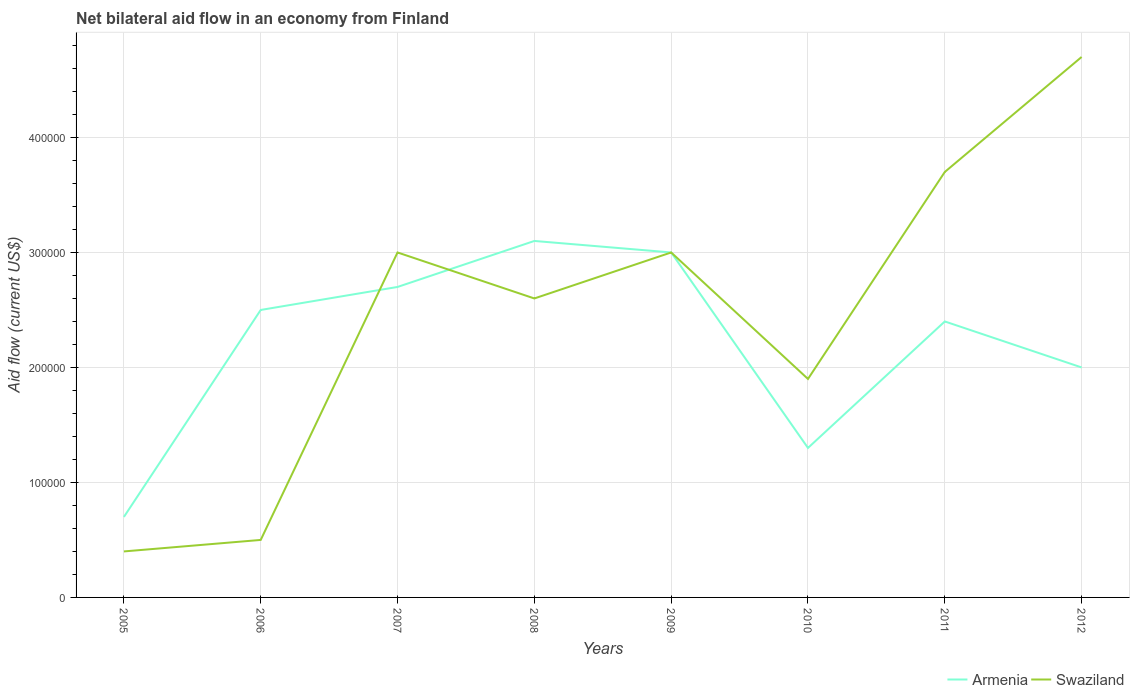How many different coloured lines are there?
Offer a very short reply. 2. In which year was the net bilateral aid flow in Swaziland maximum?
Make the answer very short. 2005. What is the total net bilateral aid flow in Armenia in the graph?
Provide a short and direct response. -1.80e+05. What is the difference between the highest and the second highest net bilateral aid flow in Swaziland?
Ensure brevity in your answer.  4.30e+05. Is the net bilateral aid flow in Armenia strictly greater than the net bilateral aid flow in Swaziland over the years?
Make the answer very short. No. How many years are there in the graph?
Your response must be concise. 8. What is the difference between two consecutive major ticks on the Y-axis?
Provide a succinct answer. 1.00e+05. Are the values on the major ticks of Y-axis written in scientific E-notation?
Provide a succinct answer. No. Does the graph contain grids?
Keep it short and to the point. Yes. Where does the legend appear in the graph?
Your response must be concise. Bottom right. How many legend labels are there?
Give a very brief answer. 2. What is the title of the graph?
Give a very brief answer. Net bilateral aid flow in an economy from Finland. Does "South Sudan" appear as one of the legend labels in the graph?
Provide a succinct answer. No. What is the Aid flow (current US$) in Armenia in 2005?
Give a very brief answer. 7.00e+04. What is the Aid flow (current US$) of Swaziland in 2005?
Your answer should be very brief. 4.00e+04. What is the Aid flow (current US$) in Armenia in 2007?
Provide a succinct answer. 2.70e+05. What is the Aid flow (current US$) of Armenia in 2008?
Your answer should be very brief. 3.10e+05. What is the Aid flow (current US$) of Swaziland in 2010?
Your answer should be compact. 1.90e+05. What is the Aid flow (current US$) of Swaziland in 2011?
Keep it short and to the point. 3.70e+05. What is the Aid flow (current US$) in Armenia in 2012?
Provide a short and direct response. 2.00e+05. What is the Aid flow (current US$) of Swaziland in 2012?
Provide a succinct answer. 4.70e+05. Across all years, what is the minimum Aid flow (current US$) of Armenia?
Your answer should be compact. 7.00e+04. What is the total Aid flow (current US$) of Armenia in the graph?
Your answer should be very brief. 1.77e+06. What is the total Aid flow (current US$) in Swaziland in the graph?
Offer a very short reply. 1.98e+06. What is the difference between the Aid flow (current US$) in Armenia in 2005 and that in 2006?
Give a very brief answer. -1.80e+05. What is the difference between the Aid flow (current US$) in Swaziland in 2005 and that in 2006?
Offer a very short reply. -10000. What is the difference between the Aid flow (current US$) in Armenia in 2005 and that in 2007?
Keep it short and to the point. -2.00e+05. What is the difference between the Aid flow (current US$) of Swaziland in 2005 and that in 2007?
Offer a terse response. -2.60e+05. What is the difference between the Aid flow (current US$) in Armenia in 2005 and that in 2008?
Give a very brief answer. -2.40e+05. What is the difference between the Aid flow (current US$) in Swaziland in 2005 and that in 2008?
Your answer should be very brief. -2.20e+05. What is the difference between the Aid flow (current US$) in Swaziland in 2005 and that in 2009?
Your answer should be compact. -2.60e+05. What is the difference between the Aid flow (current US$) in Armenia in 2005 and that in 2011?
Ensure brevity in your answer.  -1.70e+05. What is the difference between the Aid flow (current US$) of Swaziland in 2005 and that in 2011?
Give a very brief answer. -3.30e+05. What is the difference between the Aid flow (current US$) of Swaziland in 2005 and that in 2012?
Your answer should be very brief. -4.30e+05. What is the difference between the Aid flow (current US$) of Swaziland in 2006 and that in 2007?
Keep it short and to the point. -2.50e+05. What is the difference between the Aid flow (current US$) of Swaziland in 2006 and that in 2010?
Make the answer very short. -1.40e+05. What is the difference between the Aid flow (current US$) of Swaziland in 2006 and that in 2011?
Offer a very short reply. -3.20e+05. What is the difference between the Aid flow (current US$) of Swaziland in 2006 and that in 2012?
Provide a succinct answer. -4.20e+05. What is the difference between the Aid flow (current US$) in Armenia in 2007 and that in 2009?
Give a very brief answer. -3.00e+04. What is the difference between the Aid flow (current US$) in Swaziland in 2007 and that in 2009?
Your answer should be compact. 0. What is the difference between the Aid flow (current US$) in Armenia in 2007 and that in 2010?
Offer a very short reply. 1.40e+05. What is the difference between the Aid flow (current US$) of Swaziland in 2007 and that in 2010?
Offer a very short reply. 1.10e+05. What is the difference between the Aid flow (current US$) in Armenia in 2007 and that in 2011?
Make the answer very short. 3.00e+04. What is the difference between the Aid flow (current US$) of Armenia in 2007 and that in 2012?
Give a very brief answer. 7.00e+04. What is the difference between the Aid flow (current US$) of Armenia in 2008 and that in 2009?
Provide a short and direct response. 10000. What is the difference between the Aid flow (current US$) in Swaziland in 2008 and that in 2009?
Keep it short and to the point. -4.00e+04. What is the difference between the Aid flow (current US$) in Swaziland in 2008 and that in 2010?
Ensure brevity in your answer.  7.00e+04. What is the difference between the Aid flow (current US$) in Armenia in 2008 and that in 2011?
Your response must be concise. 7.00e+04. What is the difference between the Aid flow (current US$) in Armenia in 2008 and that in 2012?
Offer a terse response. 1.10e+05. What is the difference between the Aid flow (current US$) of Armenia in 2009 and that in 2010?
Provide a succinct answer. 1.70e+05. What is the difference between the Aid flow (current US$) in Swaziland in 2009 and that in 2011?
Provide a short and direct response. -7.00e+04. What is the difference between the Aid flow (current US$) of Armenia in 2009 and that in 2012?
Make the answer very short. 1.00e+05. What is the difference between the Aid flow (current US$) of Armenia in 2010 and that in 2011?
Ensure brevity in your answer.  -1.10e+05. What is the difference between the Aid flow (current US$) of Swaziland in 2010 and that in 2012?
Offer a very short reply. -2.80e+05. What is the difference between the Aid flow (current US$) of Armenia in 2005 and the Aid flow (current US$) of Swaziland in 2007?
Provide a short and direct response. -2.30e+05. What is the difference between the Aid flow (current US$) in Armenia in 2005 and the Aid flow (current US$) in Swaziland in 2012?
Provide a short and direct response. -4.00e+05. What is the difference between the Aid flow (current US$) in Armenia in 2006 and the Aid flow (current US$) in Swaziland in 2008?
Provide a succinct answer. -10000. What is the difference between the Aid flow (current US$) of Armenia in 2007 and the Aid flow (current US$) of Swaziland in 2009?
Ensure brevity in your answer.  -3.00e+04. What is the difference between the Aid flow (current US$) of Armenia in 2008 and the Aid flow (current US$) of Swaziland in 2009?
Offer a very short reply. 10000. What is the difference between the Aid flow (current US$) of Armenia in 2008 and the Aid flow (current US$) of Swaziland in 2010?
Give a very brief answer. 1.20e+05. What is the difference between the Aid flow (current US$) of Armenia in 2008 and the Aid flow (current US$) of Swaziland in 2011?
Your answer should be compact. -6.00e+04. What is the difference between the Aid flow (current US$) in Armenia in 2009 and the Aid flow (current US$) in Swaziland in 2011?
Keep it short and to the point. -7.00e+04. What is the difference between the Aid flow (current US$) of Armenia in 2010 and the Aid flow (current US$) of Swaziland in 2011?
Your answer should be very brief. -2.40e+05. What is the average Aid flow (current US$) in Armenia per year?
Offer a very short reply. 2.21e+05. What is the average Aid flow (current US$) in Swaziland per year?
Offer a terse response. 2.48e+05. In the year 2006, what is the difference between the Aid flow (current US$) in Armenia and Aid flow (current US$) in Swaziland?
Your answer should be very brief. 2.00e+05. In the year 2007, what is the difference between the Aid flow (current US$) in Armenia and Aid flow (current US$) in Swaziland?
Offer a very short reply. -3.00e+04. In the year 2010, what is the difference between the Aid flow (current US$) in Armenia and Aid flow (current US$) in Swaziland?
Ensure brevity in your answer.  -6.00e+04. In the year 2011, what is the difference between the Aid flow (current US$) of Armenia and Aid flow (current US$) of Swaziland?
Provide a succinct answer. -1.30e+05. In the year 2012, what is the difference between the Aid flow (current US$) of Armenia and Aid flow (current US$) of Swaziland?
Your response must be concise. -2.70e+05. What is the ratio of the Aid flow (current US$) of Armenia in 2005 to that in 2006?
Provide a short and direct response. 0.28. What is the ratio of the Aid flow (current US$) of Armenia in 2005 to that in 2007?
Give a very brief answer. 0.26. What is the ratio of the Aid flow (current US$) in Swaziland in 2005 to that in 2007?
Provide a short and direct response. 0.13. What is the ratio of the Aid flow (current US$) in Armenia in 2005 to that in 2008?
Make the answer very short. 0.23. What is the ratio of the Aid flow (current US$) of Swaziland in 2005 to that in 2008?
Your response must be concise. 0.15. What is the ratio of the Aid flow (current US$) of Armenia in 2005 to that in 2009?
Your answer should be compact. 0.23. What is the ratio of the Aid flow (current US$) in Swaziland in 2005 to that in 2009?
Make the answer very short. 0.13. What is the ratio of the Aid flow (current US$) in Armenia in 2005 to that in 2010?
Your answer should be compact. 0.54. What is the ratio of the Aid flow (current US$) in Swaziland in 2005 to that in 2010?
Ensure brevity in your answer.  0.21. What is the ratio of the Aid flow (current US$) in Armenia in 2005 to that in 2011?
Your answer should be very brief. 0.29. What is the ratio of the Aid flow (current US$) in Swaziland in 2005 to that in 2011?
Ensure brevity in your answer.  0.11. What is the ratio of the Aid flow (current US$) in Swaziland in 2005 to that in 2012?
Keep it short and to the point. 0.09. What is the ratio of the Aid flow (current US$) in Armenia in 2006 to that in 2007?
Provide a succinct answer. 0.93. What is the ratio of the Aid flow (current US$) of Armenia in 2006 to that in 2008?
Offer a very short reply. 0.81. What is the ratio of the Aid flow (current US$) in Swaziland in 2006 to that in 2008?
Ensure brevity in your answer.  0.19. What is the ratio of the Aid flow (current US$) in Swaziland in 2006 to that in 2009?
Your answer should be very brief. 0.17. What is the ratio of the Aid flow (current US$) in Armenia in 2006 to that in 2010?
Make the answer very short. 1.92. What is the ratio of the Aid flow (current US$) of Swaziland in 2006 to that in 2010?
Ensure brevity in your answer.  0.26. What is the ratio of the Aid flow (current US$) in Armenia in 2006 to that in 2011?
Provide a short and direct response. 1.04. What is the ratio of the Aid flow (current US$) in Swaziland in 2006 to that in 2011?
Your response must be concise. 0.14. What is the ratio of the Aid flow (current US$) in Armenia in 2006 to that in 2012?
Make the answer very short. 1.25. What is the ratio of the Aid flow (current US$) of Swaziland in 2006 to that in 2012?
Offer a very short reply. 0.11. What is the ratio of the Aid flow (current US$) of Armenia in 2007 to that in 2008?
Ensure brevity in your answer.  0.87. What is the ratio of the Aid flow (current US$) in Swaziland in 2007 to that in 2008?
Your response must be concise. 1.15. What is the ratio of the Aid flow (current US$) in Swaziland in 2007 to that in 2009?
Your response must be concise. 1. What is the ratio of the Aid flow (current US$) in Armenia in 2007 to that in 2010?
Offer a terse response. 2.08. What is the ratio of the Aid flow (current US$) in Swaziland in 2007 to that in 2010?
Your answer should be very brief. 1.58. What is the ratio of the Aid flow (current US$) in Armenia in 2007 to that in 2011?
Your answer should be very brief. 1.12. What is the ratio of the Aid flow (current US$) of Swaziland in 2007 to that in 2011?
Ensure brevity in your answer.  0.81. What is the ratio of the Aid flow (current US$) in Armenia in 2007 to that in 2012?
Make the answer very short. 1.35. What is the ratio of the Aid flow (current US$) of Swaziland in 2007 to that in 2012?
Provide a succinct answer. 0.64. What is the ratio of the Aid flow (current US$) of Swaziland in 2008 to that in 2009?
Offer a very short reply. 0.87. What is the ratio of the Aid flow (current US$) in Armenia in 2008 to that in 2010?
Offer a very short reply. 2.38. What is the ratio of the Aid flow (current US$) in Swaziland in 2008 to that in 2010?
Make the answer very short. 1.37. What is the ratio of the Aid flow (current US$) of Armenia in 2008 to that in 2011?
Offer a very short reply. 1.29. What is the ratio of the Aid flow (current US$) of Swaziland in 2008 to that in 2011?
Your answer should be very brief. 0.7. What is the ratio of the Aid flow (current US$) in Armenia in 2008 to that in 2012?
Make the answer very short. 1.55. What is the ratio of the Aid flow (current US$) of Swaziland in 2008 to that in 2012?
Ensure brevity in your answer.  0.55. What is the ratio of the Aid flow (current US$) in Armenia in 2009 to that in 2010?
Your response must be concise. 2.31. What is the ratio of the Aid flow (current US$) in Swaziland in 2009 to that in 2010?
Your answer should be compact. 1.58. What is the ratio of the Aid flow (current US$) in Swaziland in 2009 to that in 2011?
Give a very brief answer. 0.81. What is the ratio of the Aid flow (current US$) in Swaziland in 2009 to that in 2012?
Ensure brevity in your answer.  0.64. What is the ratio of the Aid flow (current US$) of Armenia in 2010 to that in 2011?
Offer a terse response. 0.54. What is the ratio of the Aid flow (current US$) of Swaziland in 2010 to that in 2011?
Offer a very short reply. 0.51. What is the ratio of the Aid flow (current US$) in Armenia in 2010 to that in 2012?
Make the answer very short. 0.65. What is the ratio of the Aid flow (current US$) in Swaziland in 2010 to that in 2012?
Make the answer very short. 0.4. What is the ratio of the Aid flow (current US$) in Armenia in 2011 to that in 2012?
Offer a terse response. 1.2. What is the ratio of the Aid flow (current US$) of Swaziland in 2011 to that in 2012?
Offer a terse response. 0.79. What is the difference between the highest and the lowest Aid flow (current US$) of Armenia?
Provide a short and direct response. 2.40e+05. What is the difference between the highest and the lowest Aid flow (current US$) in Swaziland?
Your response must be concise. 4.30e+05. 